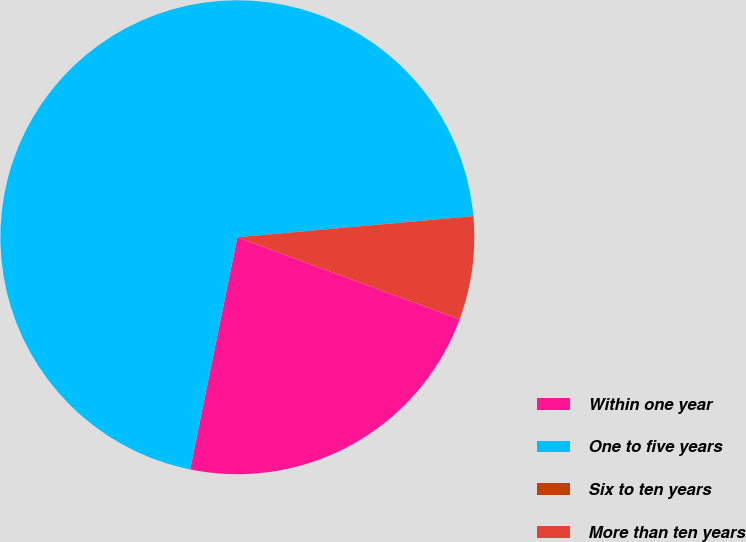<chart> <loc_0><loc_0><loc_500><loc_500><pie_chart><fcel>Within one year<fcel>One to five years<fcel>Six to ten years<fcel>More than ten years<nl><fcel>22.56%<fcel>70.38%<fcel>0.01%<fcel>7.05%<nl></chart> 